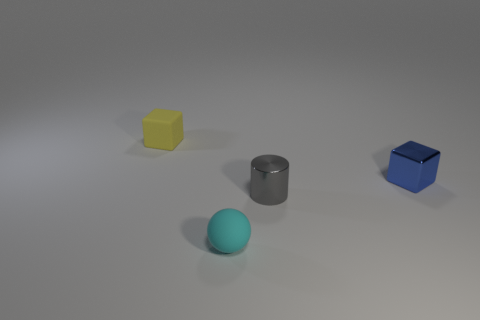How many small matte things are both in front of the rubber cube and behind the small gray shiny cylinder?
Offer a very short reply. 0. The rubber thing that is the same size as the cyan ball is what shape?
Keep it short and to the point. Cube. Are there any tiny shiny objects that are in front of the small block that is in front of the tiny matte object that is left of the tiny cyan object?
Offer a very short reply. Yes. There is a matte thing that is in front of the tiny block in front of the yellow cube; what is its size?
Your answer should be very brief. Small. How many things are either tiny blocks that are to the right of the tiny cyan matte thing or small gray metal things?
Provide a short and direct response. 2. Are there any yellow cubes of the same size as the cylinder?
Your answer should be very brief. Yes. There is a thing that is to the right of the small metallic cylinder; are there any cyan rubber things in front of it?
Ensure brevity in your answer.  Yes. How many cylinders are small yellow things or gray metal things?
Ensure brevity in your answer.  1. Are there any other tiny objects that have the same shape as the small yellow thing?
Give a very brief answer. Yes. The yellow rubber thing is what shape?
Keep it short and to the point. Cube. 